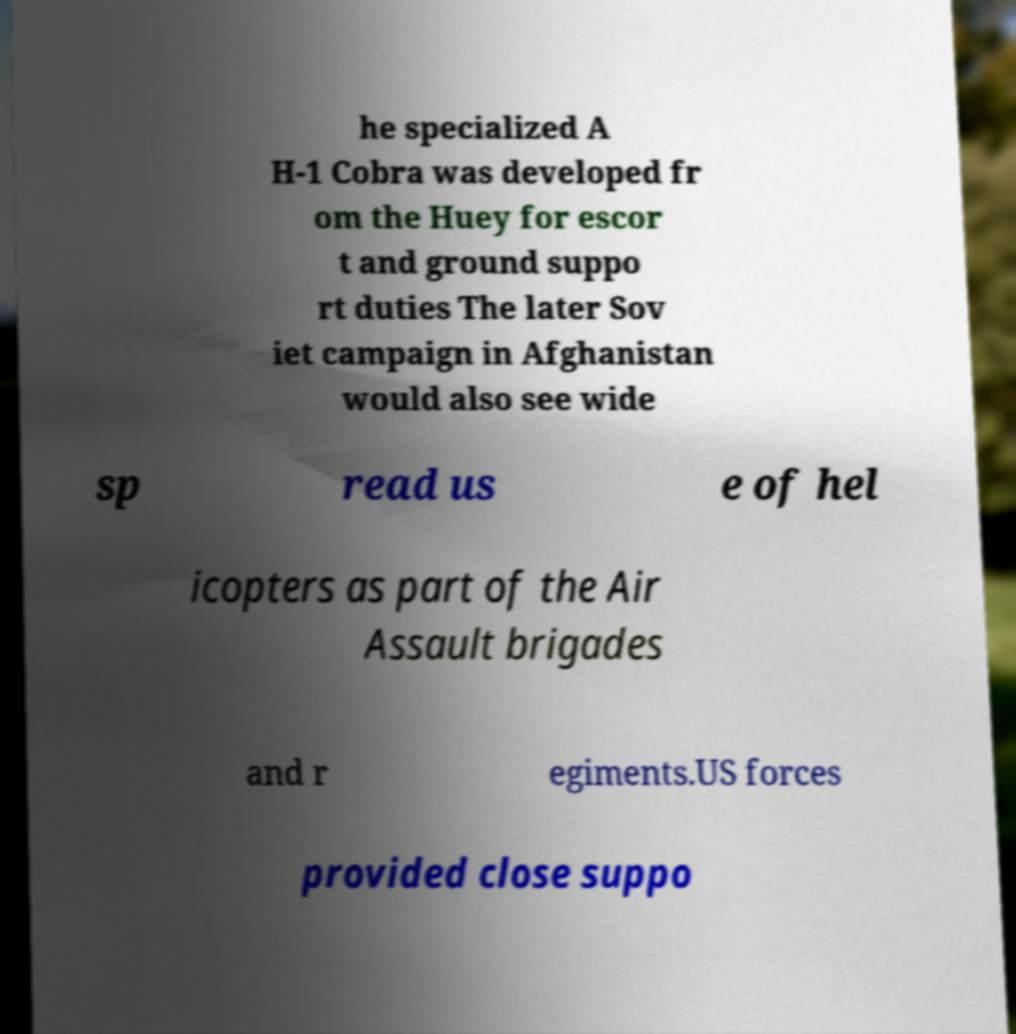Could you extract and type out the text from this image? he specialized A H-1 Cobra was developed fr om the Huey for escor t and ground suppo rt duties The later Sov iet campaign in Afghanistan would also see wide sp read us e of hel icopters as part of the Air Assault brigades and r egiments.US forces provided close suppo 